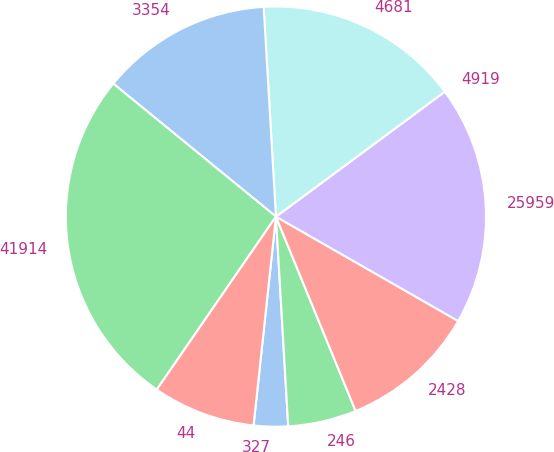Convert chart. <chart><loc_0><loc_0><loc_500><loc_500><pie_chart><fcel>327<fcel>246<fcel>2428<fcel>25959<fcel>4919<fcel>4681<fcel>3354<fcel>41914<fcel>44<nl><fcel>2.63%<fcel>5.26%<fcel>10.53%<fcel>18.42%<fcel>0.0%<fcel>15.79%<fcel>13.16%<fcel>26.31%<fcel>7.9%<nl></chart> 